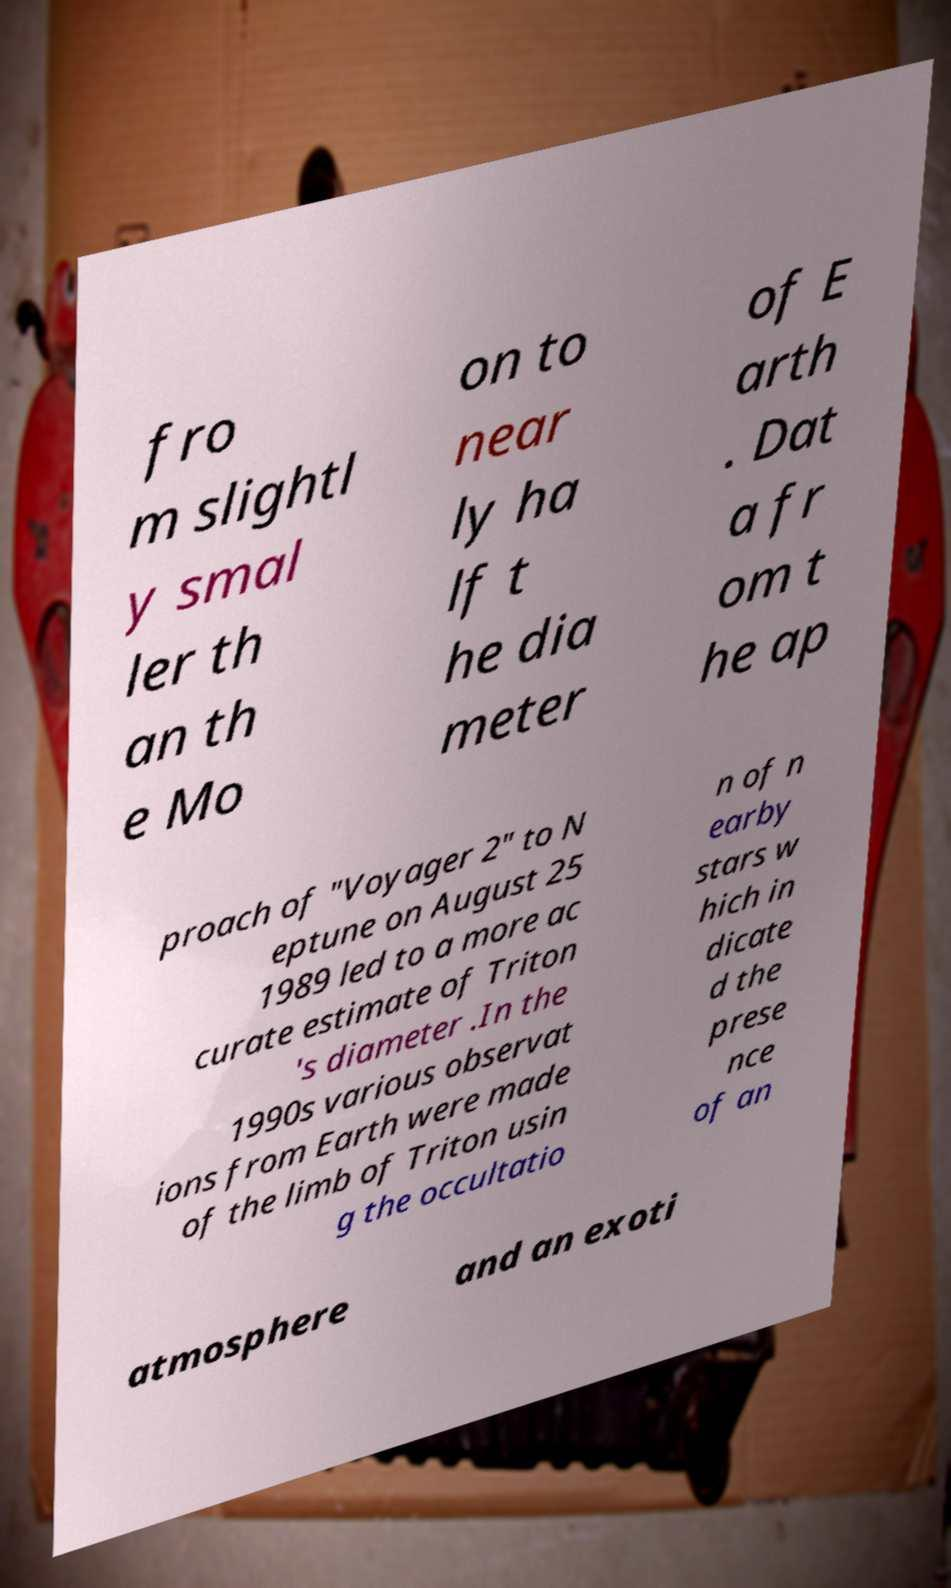Could you extract and type out the text from this image? fro m slightl y smal ler th an th e Mo on to near ly ha lf t he dia meter of E arth . Dat a fr om t he ap proach of "Voyager 2" to N eptune on August 25 1989 led to a more ac curate estimate of Triton 's diameter .In the 1990s various observat ions from Earth were made of the limb of Triton usin g the occultatio n of n earby stars w hich in dicate d the prese nce of an atmosphere and an exoti 